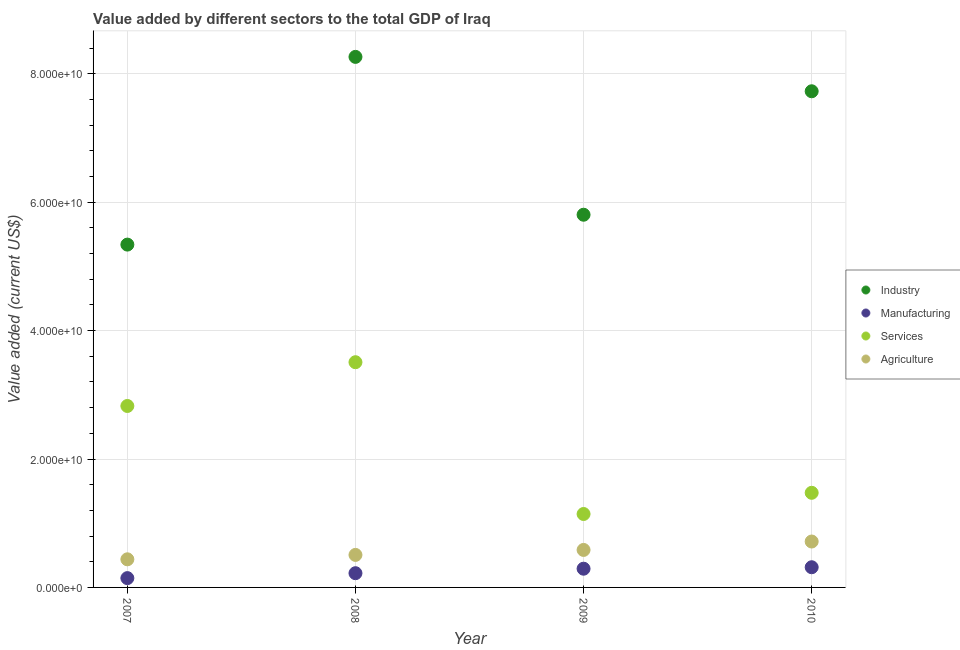How many different coloured dotlines are there?
Provide a succinct answer. 4. Is the number of dotlines equal to the number of legend labels?
Offer a very short reply. Yes. What is the value added by industrial sector in 2009?
Offer a very short reply. 5.81e+1. Across all years, what is the maximum value added by agricultural sector?
Provide a short and direct response. 7.15e+09. Across all years, what is the minimum value added by services sector?
Provide a short and direct response. 1.14e+1. In which year was the value added by manufacturing sector maximum?
Give a very brief answer. 2010. In which year was the value added by manufacturing sector minimum?
Offer a terse response. 2007. What is the total value added by services sector in the graph?
Make the answer very short. 8.95e+1. What is the difference between the value added by manufacturing sector in 2007 and that in 2008?
Offer a terse response. -7.67e+08. What is the difference between the value added by manufacturing sector in 2010 and the value added by agricultural sector in 2008?
Ensure brevity in your answer.  -1.92e+09. What is the average value added by agricultural sector per year?
Provide a succinct answer. 5.61e+09. In the year 2007, what is the difference between the value added by agricultural sector and value added by services sector?
Your answer should be very brief. -2.39e+1. What is the ratio of the value added by services sector in 2007 to that in 2009?
Provide a succinct answer. 2.47. Is the value added by agricultural sector in 2007 less than that in 2010?
Keep it short and to the point. Yes. Is the difference between the value added by industrial sector in 2007 and 2008 greater than the difference between the value added by agricultural sector in 2007 and 2008?
Your response must be concise. No. What is the difference between the highest and the second highest value added by agricultural sector?
Ensure brevity in your answer.  1.31e+09. What is the difference between the highest and the lowest value added by manufacturing sector?
Give a very brief answer. 1.70e+09. In how many years, is the value added by services sector greater than the average value added by services sector taken over all years?
Your answer should be compact. 2. Does the value added by services sector monotonically increase over the years?
Your answer should be compact. No. How many dotlines are there?
Give a very brief answer. 4. What is the difference between two consecutive major ticks on the Y-axis?
Your answer should be very brief. 2.00e+1. Where does the legend appear in the graph?
Provide a succinct answer. Center right. How are the legend labels stacked?
Keep it short and to the point. Vertical. What is the title of the graph?
Provide a short and direct response. Value added by different sectors to the total GDP of Iraq. What is the label or title of the X-axis?
Your answer should be compact. Year. What is the label or title of the Y-axis?
Give a very brief answer. Value added (current US$). What is the Value added (current US$) of Industry in 2007?
Provide a succinct answer. 5.34e+1. What is the Value added (current US$) in Manufacturing in 2007?
Keep it short and to the point. 1.45e+09. What is the Value added (current US$) of Services in 2007?
Provide a succinct answer. 2.83e+1. What is the Value added (current US$) of Agriculture in 2007?
Keep it short and to the point. 4.38e+09. What is the Value added (current US$) of Industry in 2008?
Your answer should be very brief. 8.26e+1. What is the Value added (current US$) of Manufacturing in 2008?
Provide a succinct answer. 2.22e+09. What is the Value added (current US$) of Services in 2008?
Give a very brief answer. 3.51e+1. What is the Value added (current US$) in Agriculture in 2008?
Offer a terse response. 5.06e+09. What is the Value added (current US$) of Industry in 2009?
Offer a very short reply. 5.81e+1. What is the Value added (current US$) in Manufacturing in 2009?
Keep it short and to the point. 2.92e+09. What is the Value added (current US$) of Services in 2009?
Your answer should be compact. 1.14e+1. What is the Value added (current US$) in Agriculture in 2009?
Provide a succinct answer. 5.84e+09. What is the Value added (current US$) of Industry in 2010?
Your answer should be very brief. 7.73e+1. What is the Value added (current US$) in Manufacturing in 2010?
Ensure brevity in your answer.  3.14e+09. What is the Value added (current US$) in Services in 2010?
Offer a terse response. 1.47e+1. What is the Value added (current US$) in Agriculture in 2010?
Ensure brevity in your answer.  7.15e+09. Across all years, what is the maximum Value added (current US$) of Industry?
Provide a short and direct response. 8.26e+1. Across all years, what is the maximum Value added (current US$) in Manufacturing?
Keep it short and to the point. 3.14e+09. Across all years, what is the maximum Value added (current US$) of Services?
Make the answer very short. 3.51e+1. Across all years, what is the maximum Value added (current US$) of Agriculture?
Provide a short and direct response. 7.15e+09. Across all years, what is the minimum Value added (current US$) of Industry?
Make the answer very short. 5.34e+1. Across all years, what is the minimum Value added (current US$) of Manufacturing?
Your answer should be compact. 1.45e+09. Across all years, what is the minimum Value added (current US$) of Services?
Your response must be concise. 1.14e+1. Across all years, what is the minimum Value added (current US$) of Agriculture?
Your answer should be very brief. 4.38e+09. What is the total Value added (current US$) of Industry in the graph?
Give a very brief answer. 2.71e+11. What is the total Value added (current US$) in Manufacturing in the graph?
Your answer should be compact. 9.73e+09. What is the total Value added (current US$) in Services in the graph?
Make the answer very short. 8.95e+1. What is the total Value added (current US$) in Agriculture in the graph?
Provide a short and direct response. 2.24e+1. What is the difference between the Value added (current US$) of Industry in 2007 and that in 2008?
Offer a very short reply. -2.92e+1. What is the difference between the Value added (current US$) of Manufacturing in 2007 and that in 2008?
Offer a very short reply. -7.67e+08. What is the difference between the Value added (current US$) of Services in 2007 and that in 2008?
Your response must be concise. -6.82e+09. What is the difference between the Value added (current US$) of Agriculture in 2007 and that in 2008?
Your response must be concise. -6.85e+08. What is the difference between the Value added (current US$) in Industry in 2007 and that in 2009?
Provide a short and direct response. -4.65e+09. What is the difference between the Value added (current US$) of Manufacturing in 2007 and that in 2009?
Ensure brevity in your answer.  -1.47e+09. What is the difference between the Value added (current US$) in Services in 2007 and that in 2009?
Keep it short and to the point. 1.68e+1. What is the difference between the Value added (current US$) of Agriculture in 2007 and that in 2009?
Make the answer very short. -1.46e+09. What is the difference between the Value added (current US$) of Industry in 2007 and that in 2010?
Ensure brevity in your answer.  -2.39e+1. What is the difference between the Value added (current US$) of Manufacturing in 2007 and that in 2010?
Ensure brevity in your answer.  -1.70e+09. What is the difference between the Value added (current US$) in Services in 2007 and that in 2010?
Provide a short and direct response. 1.35e+1. What is the difference between the Value added (current US$) in Agriculture in 2007 and that in 2010?
Give a very brief answer. -2.77e+09. What is the difference between the Value added (current US$) in Industry in 2008 and that in 2009?
Ensure brevity in your answer.  2.46e+1. What is the difference between the Value added (current US$) in Manufacturing in 2008 and that in 2009?
Your answer should be very brief. -6.99e+08. What is the difference between the Value added (current US$) in Services in 2008 and that in 2009?
Make the answer very short. 2.36e+1. What is the difference between the Value added (current US$) in Agriculture in 2008 and that in 2009?
Make the answer very short. -7.76e+08. What is the difference between the Value added (current US$) of Industry in 2008 and that in 2010?
Provide a short and direct response. 5.36e+09. What is the difference between the Value added (current US$) in Manufacturing in 2008 and that in 2010?
Your answer should be compact. -9.28e+08. What is the difference between the Value added (current US$) of Services in 2008 and that in 2010?
Offer a terse response. 2.03e+1. What is the difference between the Value added (current US$) in Agriculture in 2008 and that in 2010?
Offer a terse response. -2.09e+09. What is the difference between the Value added (current US$) of Industry in 2009 and that in 2010?
Offer a very short reply. -1.92e+1. What is the difference between the Value added (current US$) of Manufacturing in 2009 and that in 2010?
Your response must be concise. -2.29e+08. What is the difference between the Value added (current US$) of Services in 2009 and that in 2010?
Ensure brevity in your answer.  -3.30e+09. What is the difference between the Value added (current US$) in Agriculture in 2009 and that in 2010?
Your answer should be compact. -1.31e+09. What is the difference between the Value added (current US$) in Industry in 2007 and the Value added (current US$) in Manufacturing in 2008?
Offer a very short reply. 5.12e+1. What is the difference between the Value added (current US$) in Industry in 2007 and the Value added (current US$) in Services in 2008?
Provide a short and direct response. 1.83e+1. What is the difference between the Value added (current US$) of Industry in 2007 and the Value added (current US$) of Agriculture in 2008?
Give a very brief answer. 4.83e+1. What is the difference between the Value added (current US$) in Manufacturing in 2007 and the Value added (current US$) in Services in 2008?
Your answer should be compact. -3.36e+1. What is the difference between the Value added (current US$) in Manufacturing in 2007 and the Value added (current US$) in Agriculture in 2008?
Your answer should be very brief. -3.62e+09. What is the difference between the Value added (current US$) in Services in 2007 and the Value added (current US$) in Agriculture in 2008?
Keep it short and to the point. 2.32e+1. What is the difference between the Value added (current US$) in Industry in 2007 and the Value added (current US$) in Manufacturing in 2009?
Make the answer very short. 5.05e+1. What is the difference between the Value added (current US$) in Industry in 2007 and the Value added (current US$) in Services in 2009?
Offer a very short reply. 4.20e+1. What is the difference between the Value added (current US$) in Industry in 2007 and the Value added (current US$) in Agriculture in 2009?
Your response must be concise. 4.76e+1. What is the difference between the Value added (current US$) in Manufacturing in 2007 and the Value added (current US$) in Services in 2009?
Ensure brevity in your answer.  -9.99e+09. What is the difference between the Value added (current US$) of Manufacturing in 2007 and the Value added (current US$) of Agriculture in 2009?
Offer a very short reply. -4.39e+09. What is the difference between the Value added (current US$) in Services in 2007 and the Value added (current US$) in Agriculture in 2009?
Ensure brevity in your answer.  2.24e+1. What is the difference between the Value added (current US$) in Industry in 2007 and the Value added (current US$) in Manufacturing in 2010?
Make the answer very short. 5.03e+1. What is the difference between the Value added (current US$) of Industry in 2007 and the Value added (current US$) of Services in 2010?
Your answer should be very brief. 3.87e+1. What is the difference between the Value added (current US$) in Industry in 2007 and the Value added (current US$) in Agriculture in 2010?
Offer a terse response. 4.62e+1. What is the difference between the Value added (current US$) of Manufacturing in 2007 and the Value added (current US$) of Services in 2010?
Keep it short and to the point. -1.33e+1. What is the difference between the Value added (current US$) in Manufacturing in 2007 and the Value added (current US$) in Agriculture in 2010?
Provide a short and direct response. -5.70e+09. What is the difference between the Value added (current US$) of Services in 2007 and the Value added (current US$) of Agriculture in 2010?
Offer a very short reply. 2.11e+1. What is the difference between the Value added (current US$) in Industry in 2008 and the Value added (current US$) in Manufacturing in 2009?
Offer a very short reply. 7.97e+1. What is the difference between the Value added (current US$) in Industry in 2008 and the Value added (current US$) in Services in 2009?
Offer a terse response. 7.12e+1. What is the difference between the Value added (current US$) of Industry in 2008 and the Value added (current US$) of Agriculture in 2009?
Your answer should be very brief. 7.68e+1. What is the difference between the Value added (current US$) of Manufacturing in 2008 and the Value added (current US$) of Services in 2009?
Provide a succinct answer. -9.22e+09. What is the difference between the Value added (current US$) of Manufacturing in 2008 and the Value added (current US$) of Agriculture in 2009?
Make the answer very short. -3.62e+09. What is the difference between the Value added (current US$) in Services in 2008 and the Value added (current US$) in Agriculture in 2009?
Provide a short and direct response. 2.92e+1. What is the difference between the Value added (current US$) of Industry in 2008 and the Value added (current US$) of Manufacturing in 2010?
Ensure brevity in your answer.  7.95e+1. What is the difference between the Value added (current US$) of Industry in 2008 and the Value added (current US$) of Services in 2010?
Your answer should be compact. 6.79e+1. What is the difference between the Value added (current US$) in Industry in 2008 and the Value added (current US$) in Agriculture in 2010?
Make the answer very short. 7.55e+1. What is the difference between the Value added (current US$) in Manufacturing in 2008 and the Value added (current US$) in Services in 2010?
Your answer should be compact. -1.25e+1. What is the difference between the Value added (current US$) of Manufacturing in 2008 and the Value added (current US$) of Agriculture in 2010?
Ensure brevity in your answer.  -4.93e+09. What is the difference between the Value added (current US$) of Services in 2008 and the Value added (current US$) of Agriculture in 2010?
Keep it short and to the point. 2.79e+1. What is the difference between the Value added (current US$) of Industry in 2009 and the Value added (current US$) of Manufacturing in 2010?
Provide a short and direct response. 5.49e+1. What is the difference between the Value added (current US$) of Industry in 2009 and the Value added (current US$) of Services in 2010?
Your response must be concise. 4.33e+1. What is the difference between the Value added (current US$) of Industry in 2009 and the Value added (current US$) of Agriculture in 2010?
Ensure brevity in your answer.  5.09e+1. What is the difference between the Value added (current US$) of Manufacturing in 2009 and the Value added (current US$) of Services in 2010?
Provide a succinct answer. -1.18e+1. What is the difference between the Value added (current US$) in Manufacturing in 2009 and the Value added (current US$) in Agriculture in 2010?
Offer a very short reply. -4.23e+09. What is the difference between the Value added (current US$) in Services in 2009 and the Value added (current US$) in Agriculture in 2010?
Your response must be concise. 4.29e+09. What is the average Value added (current US$) of Industry per year?
Your answer should be very brief. 6.78e+1. What is the average Value added (current US$) in Manufacturing per year?
Make the answer very short. 2.43e+09. What is the average Value added (current US$) of Services per year?
Your answer should be compact. 2.24e+1. What is the average Value added (current US$) in Agriculture per year?
Provide a succinct answer. 5.61e+09. In the year 2007, what is the difference between the Value added (current US$) of Industry and Value added (current US$) of Manufacturing?
Make the answer very short. 5.20e+1. In the year 2007, what is the difference between the Value added (current US$) in Industry and Value added (current US$) in Services?
Your answer should be very brief. 2.51e+1. In the year 2007, what is the difference between the Value added (current US$) in Industry and Value added (current US$) in Agriculture?
Ensure brevity in your answer.  4.90e+1. In the year 2007, what is the difference between the Value added (current US$) in Manufacturing and Value added (current US$) in Services?
Give a very brief answer. -2.68e+1. In the year 2007, what is the difference between the Value added (current US$) of Manufacturing and Value added (current US$) of Agriculture?
Give a very brief answer. -2.93e+09. In the year 2007, what is the difference between the Value added (current US$) in Services and Value added (current US$) in Agriculture?
Ensure brevity in your answer.  2.39e+1. In the year 2008, what is the difference between the Value added (current US$) in Industry and Value added (current US$) in Manufacturing?
Make the answer very short. 8.04e+1. In the year 2008, what is the difference between the Value added (current US$) of Industry and Value added (current US$) of Services?
Provide a succinct answer. 4.76e+1. In the year 2008, what is the difference between the Value added (current US$) of Industry and Value added (current US$) of Agriculture?
Offer a terse response. 7.76e+1. In the year 2008, what is the difference between the Value added (current US$) of Manufacturing and Value added (current US$) of Services?
Your answer should be compact. -3.29e+1. In the year 2008, what is the difference between the Value added (current US$) of Manufacturing and Value added (current US$) of Agriculture?
Give a very brief answer. -2.85e+09. In the year 2008, what is the difference between the Value added (current US$) of Services and Value added (current US$) of Agriculture?
Ensure brevity in your answer.  3.00e+1. In the year 2009, what is the difference between the Value added (current US$) in Industry and Value added (current US$) in Manufacturing?
Make the answer very short. 5.51e+1. In the year 2009, what is the difference between the Value added (current US$) of Industry and Value added (current US$) of Services?
Offer a terse response. 4.66e+1. In the year 2009, what is the difference between the Value added (current US$) in Industry and Value added (current US$) in Agriculture?
Ensure brevity in your answer.  5.22e+1. In the year 2009, what is the difference between the Value added (current US$) of Manufacturing and Value added (current US$) of Services?
Give a very brief answer. -8.52e+09. In the year 2009, what is the difference between the Value added (current US$) of Manufacturing and Value added (current US$) of Agriculture?
Your answer should be compact. -2.92e+09. In the year 2009, what is the difference between the Value added (current US$) in Services and Value added (current US$) in Agriculture?
Give a very brief answer. 5.60e+09. In the year 2010, what is the difference between the Value added (current US$) in Industry and Value added (current US$) in Manufacturing?
Your response must be concise. 7.41e+1. In the year 2010, what is the difference between the Value added (current US$) of Industry and Value added (current US$) of Services?
Make the answer very short. 6.25e+1. In the year 2010, what is the difference between the Value added (current US$) in Industry and Value added (current US$) in Agriculture?
Make the answer very short. 7.01e+1. In the year 2010, what is the difference between the Value added (current US$) of Manufacturing and Value added (current US$) of Services?
Give a very brief answer. -1.16e+1. In the year 2010, what is the difference between the Value added (current US$) of Manufacturing and Value added (current US$) of Agriculture?
Your answer should be compact. -4.01e+09. In the year 2010, what is the difference between the Value added (current US$) in Services and Value added (current US$) in Agriculture?
Provide a succinct answer. 7.59e+09. What is the ratio of the Value added (current US$) of Industry in 2007 to that in 2008?
Your answer should be very brief. 0.65. What is the ratio of the Value added (current US$) in Manufacturing in 2007 to that in 2008?
Keep it short and to the point. 0.65. What is the ratio of the Value added (current US$) in Services in 2007 to that in 2008?
Give a very brief answer. 0.81. What is the ratio of the Value added (current US$) of Agriculture in 2007 to that in 2008?
Ensure brevity in your answer.  0.86. What is the ratio of the Value added (current US$) of Industry in 2007 to that in 2009?
Your response must be concise. 0.92. What is the ratio of the Value added (current US$) in Manufacturing in 2007 to that in 2009?
Offer a very short reply. 0.5. What is the ratio of the Value added (current US$) in Services in 2007 to that in 2009?
Provide a succinct answer. 2.47. What is the ratio of the Value added (current US$) in Agriculture in 2007 to that in 2009?
Provide a succinct answer. 0.75. What is the ratio of the Value added (current US$) of Industry in 2007 to that in 2010?
Keep it short and to the point. 0.69. What is the ratio of the Value added (current US$) of Manufacturing in 2007 to that in 2010?
Keep it short and to the point. 0.46. What is the ratio of the Value added (current US$) in Services in 2007 to that in 2010?
Give a very brief answer. 1.92. What is the ratio of the Value added (current US$) of Agriculture in 2007 to that in 2010?
Make the answer very short. 0.61. What is the ratio of the Value added (current US$) in Industry in 2008 to that in 2009?
Keep it short and to the point. 1.42. What is the ratio of the Value added (current US$) of Manufacturing in 2008 to that in 2009?
Your response must be concise. 0.76. What is the ratio of the Value added (current US$) in Services in 2008 to that in 2009?
Your response must be concise. 3.07. What is the ratio of the Value added (current US$) of Agriculture in 2008 to that in 2009?
Offer a very short reply. 0.87. What is the ratio of the Value added (current US$) of Industry in 2008 to that in 2010?
Your answer should be very brief. 1.07. What is the ratio of the Value added (current US$) of Manufacturing in 2008 to that in 2010?
Offer a very short reply. 0.7. What is the ratio of the Value added (current US$) of Services in 2008 to that in 2010?
Make the answer very short. 2.38. What is the ratio of the Value added (current US$) in Agriculture in 2008 to that in 2010?
Offer a very short reply. 0.71. What is the ratio of the Value added (current US$) of Industry in 2009 to that in 2010?
Offer a very short reply. 0.75. What is the ratio of the Value added (current US$) in Manufacturing in 2009 to that in 2010?
Make the answer very short. 0.93. What is the ratio of the Value added (current US$) of Services in 2009 to that in 2010?
Make the answer very short. 0.78. What is the ratio of the Value added (current US$) of Agriculture in 2009 to that in 2010?
Your answer should be very brief. 0.82. What is the difference between the highest and the second highest Value added (current US$) in Industry?
Give a very brief answer. 5.36e+09. What is the difference between the highest and the second highest Value added (current US$) of Manufacturing?
Provide a short and direct response. 2.29e+08. What is the difference between the highest and the second highest Value added (current US$) in Services?
Provide a short and direct response. 6.82e+09. What is the difference between the highest and the second highest Value added (current US$) of Agriculture?
Provide a succinct answer. 1.31e+09. What is the difference between the highest and the lowest Value added (current US$) of Industry?
Your response must be concise. 2.92e+1. What is the difference between the highest and the lowest Value added (current US$) of Manufacturing?
Keep it short and to the point. 1.70e+09. What is the difference between the highest and the lowest Value added (current US$) of Services?
Provide a short and direct response. 2.36e+1. What is the difference between the highest and the lowest Value added (current US$) of Agriculture?
Ensure brevity in your answer.  2.77e+09. 